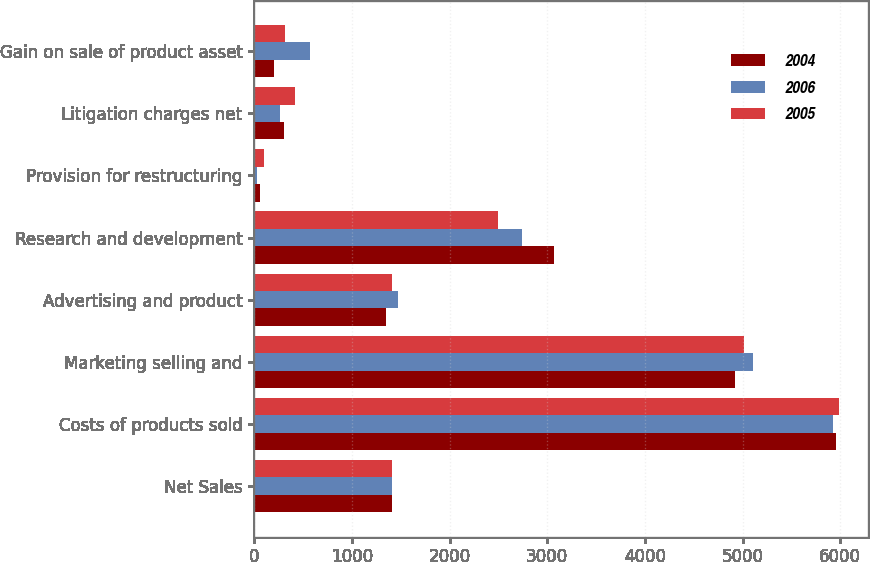Convert chart to OTSL. <chart><loc_0><loc_0><loc_500><loc_500><stacked_bar_chart><ecel><fcel>Net Sales<fcel>Costs of products sold<fcel>Marketing selling and<fcel>Advertising and product<fcel>Research and development<fcel>Provision for restructuring<fcel>Litigation charges net<fcel>Gain on sale of product asset<nl><fcel>2004<fcel>1411<fcel>5956<fcel>4919<fcel>1351<fcel>3067<fcel>59<fcel>302<fcel>200<nl><fcel>2006<fcel>1411<fcel>5928<fcel>5106<fcel>1476<fcel>2746<fcel>32<fcel>269<fcel>569<nl><fcel>2005<fcel>1411<fcel>5989<fcel>5016<fcel>1411<fcel>2500<fcel>104<fcel>420<fcel>320<nl></chart> 